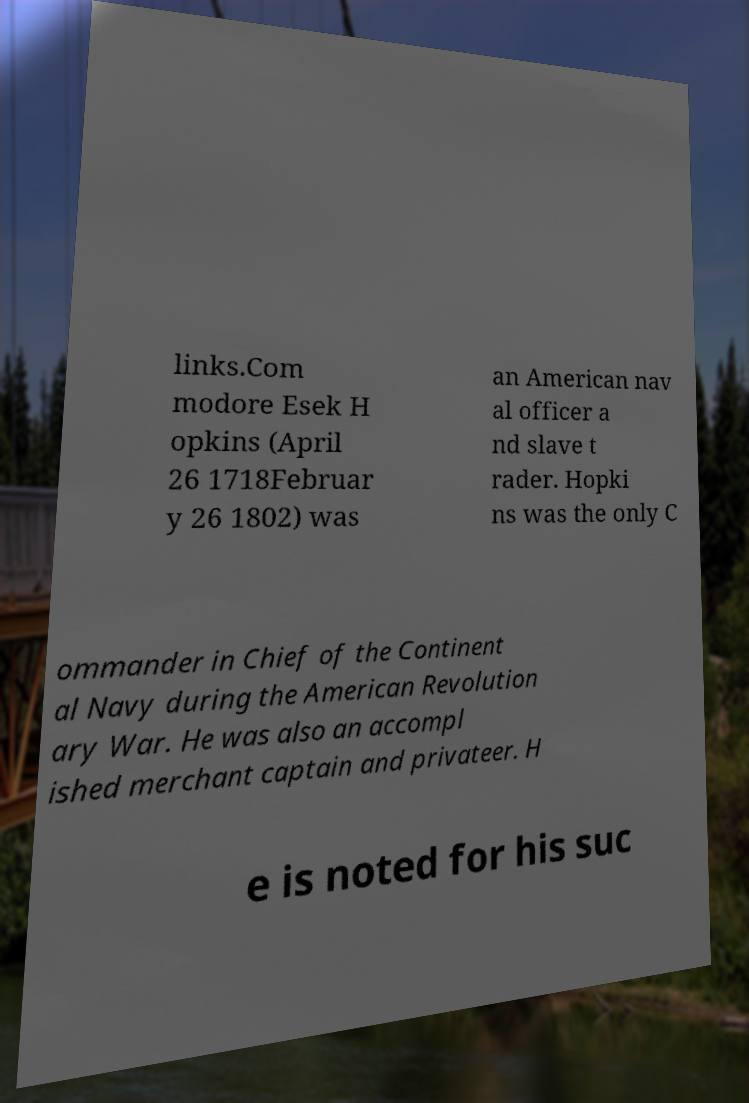For documentation purposes, I need the text within this image transcribed. Could you provide that? links.Com modore Esek H opkins (April 26 1718Februar y 26 1802) was an American nav al officer a nd slave t rader. Hopki ns was the only C ommander in Chief of the Continent al Navy during the American Revolution ary War. He was also an accompl ished merchant captain and privateer. H e is noted for his suc 